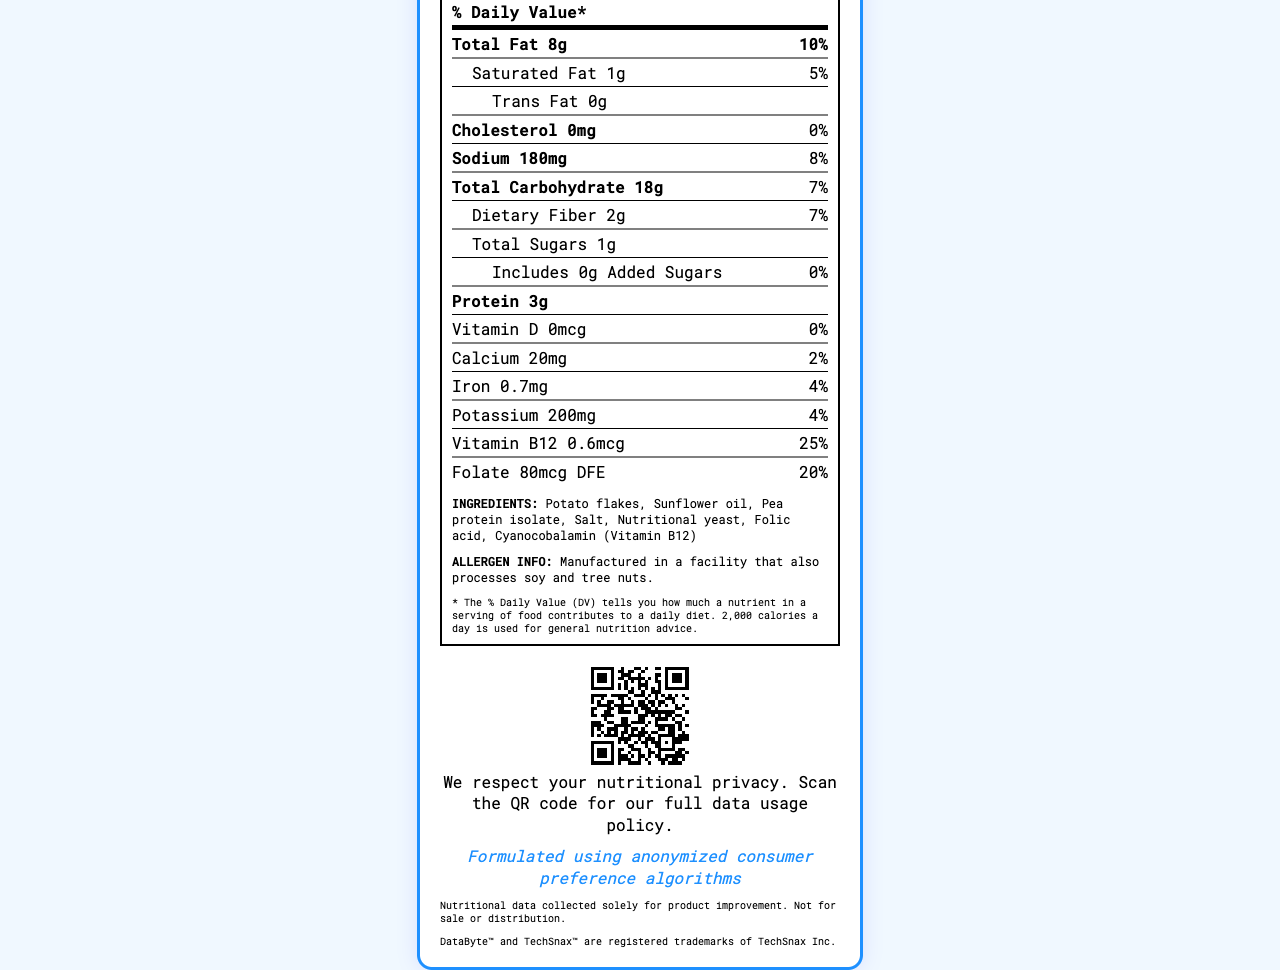what is the product name? The product name is displayed at the top of the document.
Answer: DataByte Crunchers how many servings per container are there? The document states "8 servings per container" in the nutrition label section.
Answer: 8 what is the serving size? The document specifies the serving size as "30g (about 15 chips)".
Answer: 30g (about 15 chips) what is the protein content per serving? The protein content is listed as "Protein 3g" in the nutrient section.
Answer: 3g who manufactures DataByte Crunchers? The company information at the bottom of the document lists "TechSnax Inc."
Answer: TechSnax Inc. what is the calorie count per serving? The document states the calorie count as "Calories 150" in the nutrient section.
Answer: 150 how much sodium does each serving contain? The sodium content is stated as "Sodium 180mg (8% DV)".
Answer: 180mg what is the total carbohydrate content per serving? A. 7g B. 18g C. 25g D. 10g The total carbohydrate content is listed as "Total Carbohydrate 18g (7% DV)".
Answer: B Which of the following nutrients does DataByte Crunchers provide 0% daily value of? i. Vitamin D ii. Sodium iii. Protein iv. Cholesterol The document lists "Vitamin D 0%" and "Cholesterol 0%".
Answer: i and iv does the product contain any trans fat? The document states "Trans Fat 0g" in the nutrient section.
Answer: No is there any added sugar in DataByte Crunchers? The document shows "Includes 0g Added Sugars" under the total sugars section.
Answer: No could we determine if DataByte Crunchers are gluten-free from the label? The document does not provide information about whether the product is gluten-free.
Answer: Not enough information summarize the main idea of the document. The document provides comprehensive nutritional information about DataByte Crunchers, an overview of ingredient and micronutrient details, QR code for more data, and legal disclaimers. It emphasizes data-driven formulation and respects nutritional privacy.
Answer: The document is a nutrition facts label for DataByte Crunchers, providing detailed information about serving size, calories, nutrient content, ingredients, allergen information, and a QR code for expanded nutritional data. It also includes a claim about the product being formulated using anonymized consumer preference algorithms and legal disclaimers about nutritional data usage. 